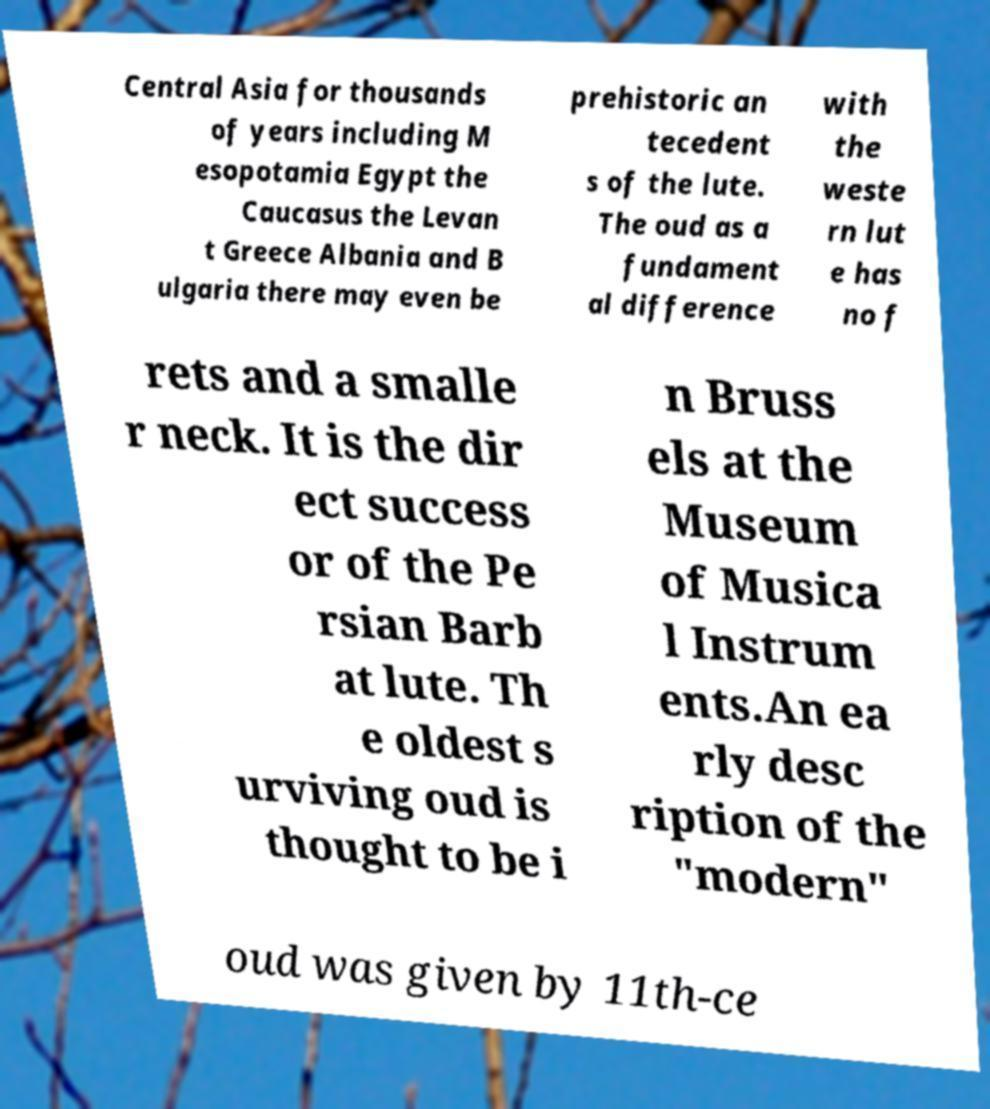Could you extract and type out the text from this image? Central Asia for thousands of years including M esopotamia Egypt the Caucasus the Levan t Greece Albania and B ulgaria there may even be prehistoric an tecedent s of the lute. The oud as a fundament al difference with the weste rn lut e has no f rets and a smalle r neck. It is the dir ect success or of the Pe rsian Barb at lute. Th e oldest s urviving oud is thought to be i n Bruss els at the Museum of Musica l Instrum ents.An ea rly desc ription of the "modern" oud was given by 11th-ce 